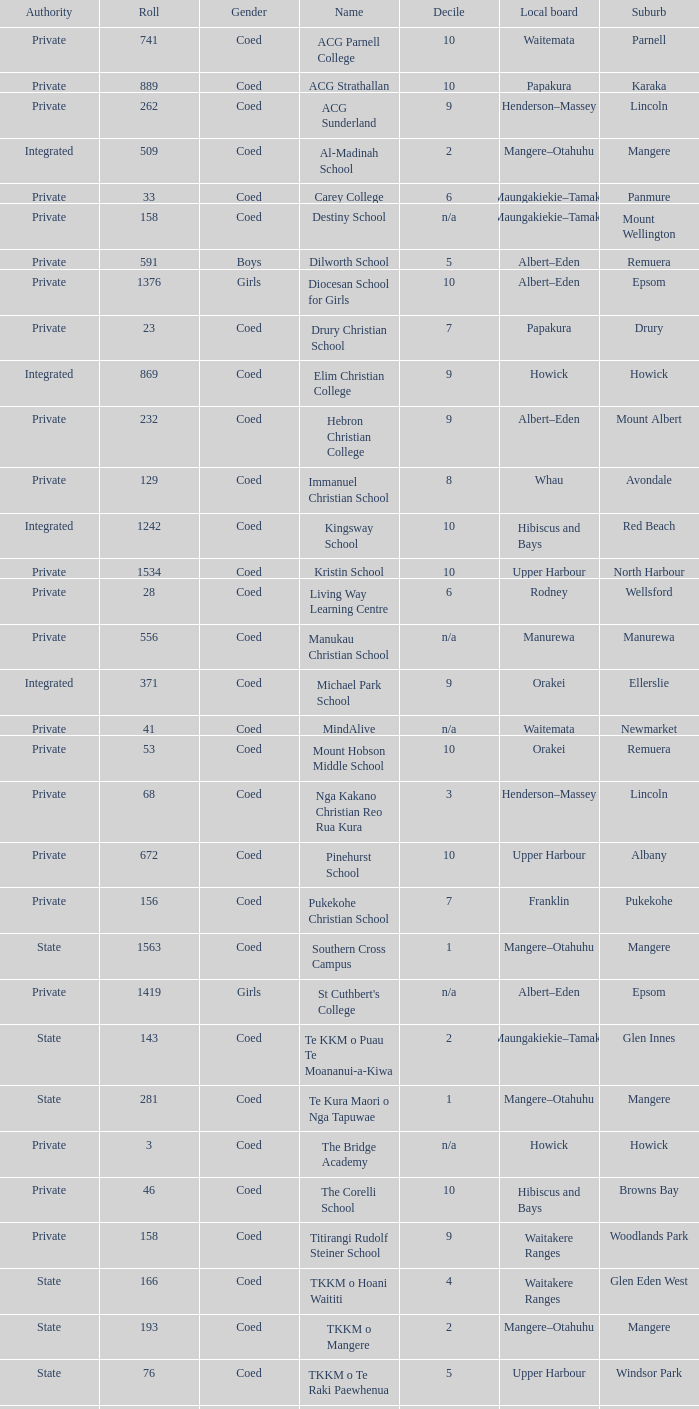What is the name when the local board is albert–eden, and a Decile of 9? Hebron Christian College. 